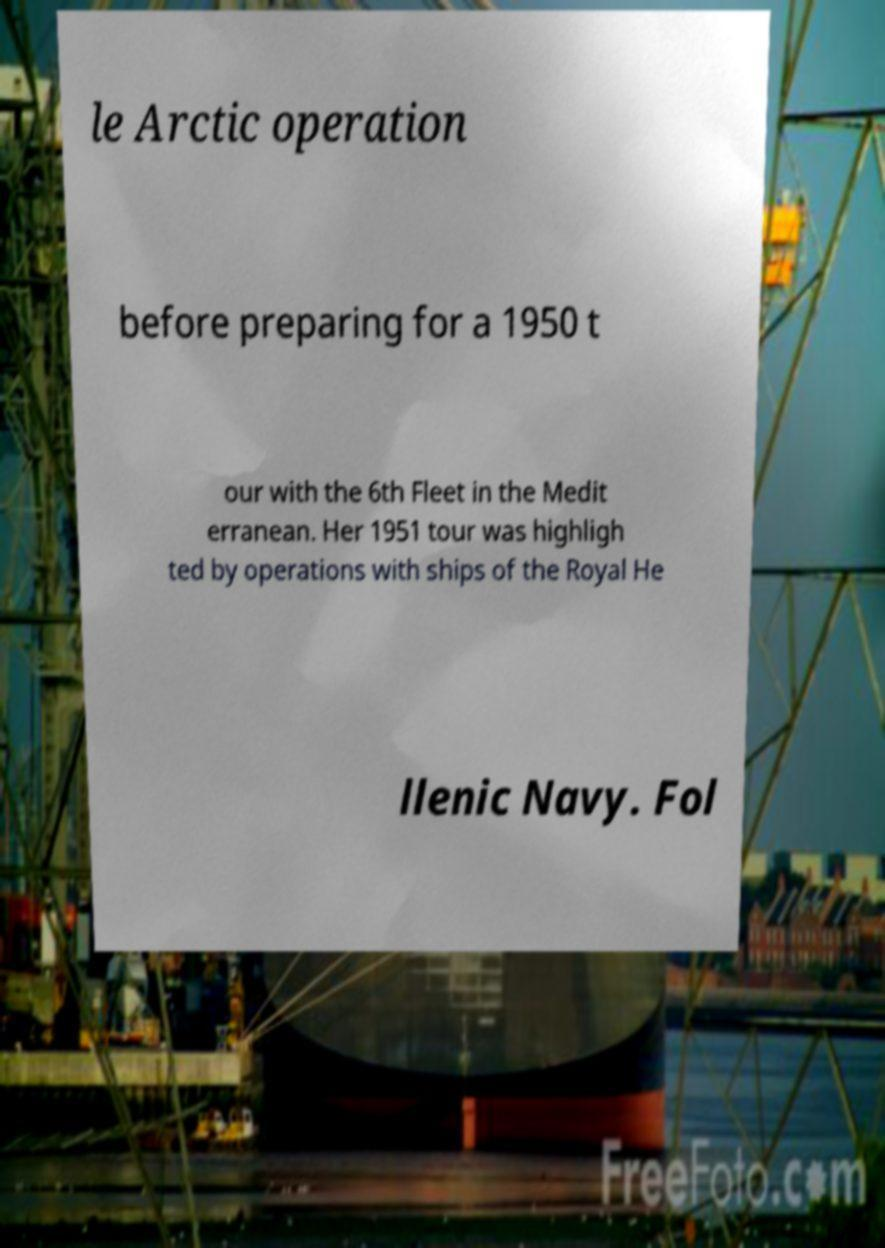I need the written content from this picture converted into text. Can you do that? le Arctic operation before preparing for a 1950 t our with the 6th Fleet in the Medit erranean. Her 1951 tour was highligh ted by operations with ships of the Royal He llenic Navy. Fol 